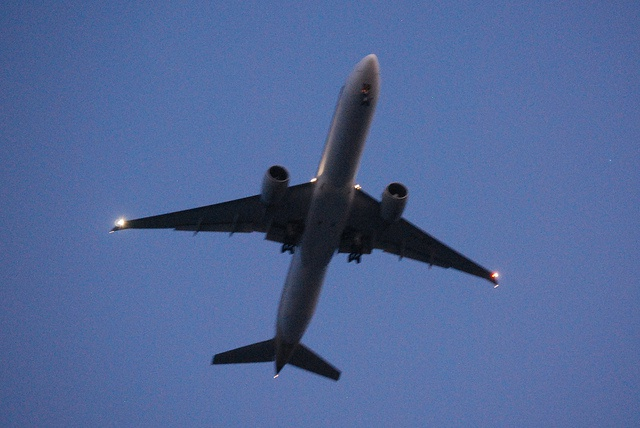Describe the objects in this image and their specific colors. I can see a airplane in blue, black, and gray tones in this image. 